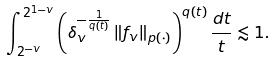<formula> <loc_0><loc_0><loc_500><loc_500>\int _ { 2 ^ { - v } } ^ { 2 ^ { 1 - v } } \left ( \delta _ { v } ^ { - \frac { 1 } { q ( t ) } } \left \| f _ { v } \right \| _ { p ( \cdot ) } \right ) ^ { q ( t ) } \frac { d t } { t } \lesssim 1 .</formula> 